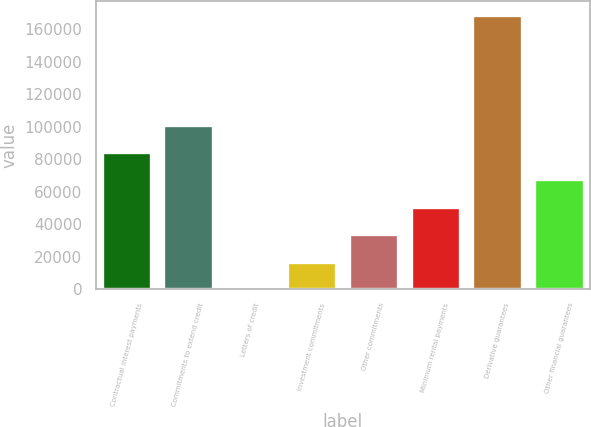<chart> <loc_0><loc_0><loc_500><loc_500><bar_chart><fcel>Contractual interest payments<fcel>Commitments to extend credit<fcel>Letters of credit<fcel>Investment commitments<fcel>Other commitments<fcel>Minimum rental payments<fcel>Derivative guarantees<fcel>Other financial guarantees<nl><fcel>84404.5<fcel>101280<fcel>25<fcel>16900.9<fcel>33776.8<fcel>50652.7<fcel>168784<fcel>67528.6<nl></chart> 